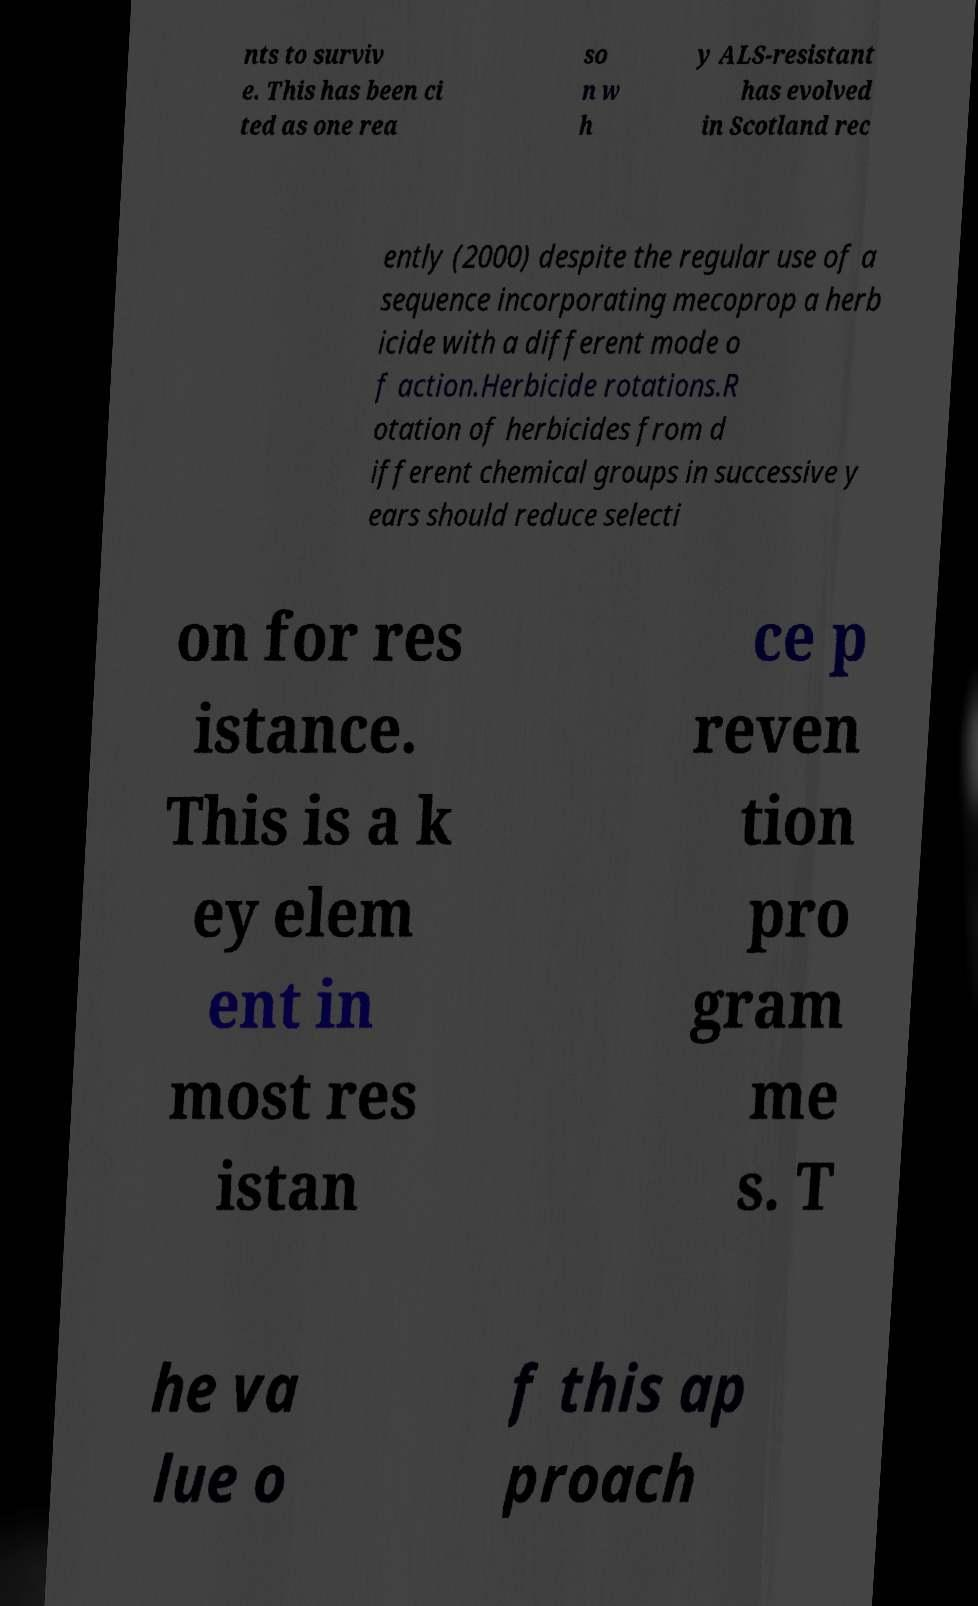Can you read and provide the text displayed in the image?This photo seems to have some interesting text. Can you extract and type it out for me? nts to surviv e. This has been ci ted as one rea so n w h y ALS-resistant has evolved in Scotland rec ently (2000) despite the regular use of a sequence incorporating mecoprop a herb icide with a different mode o f action.Herbicide rotations.R otation of herbicides from d ifferent chemical groups in successive y ears should reduce selecti on for res istance. This is a k ey elem ent in most res istan ce p reven tion pro gram me s. T he va lue o f this ap proach 